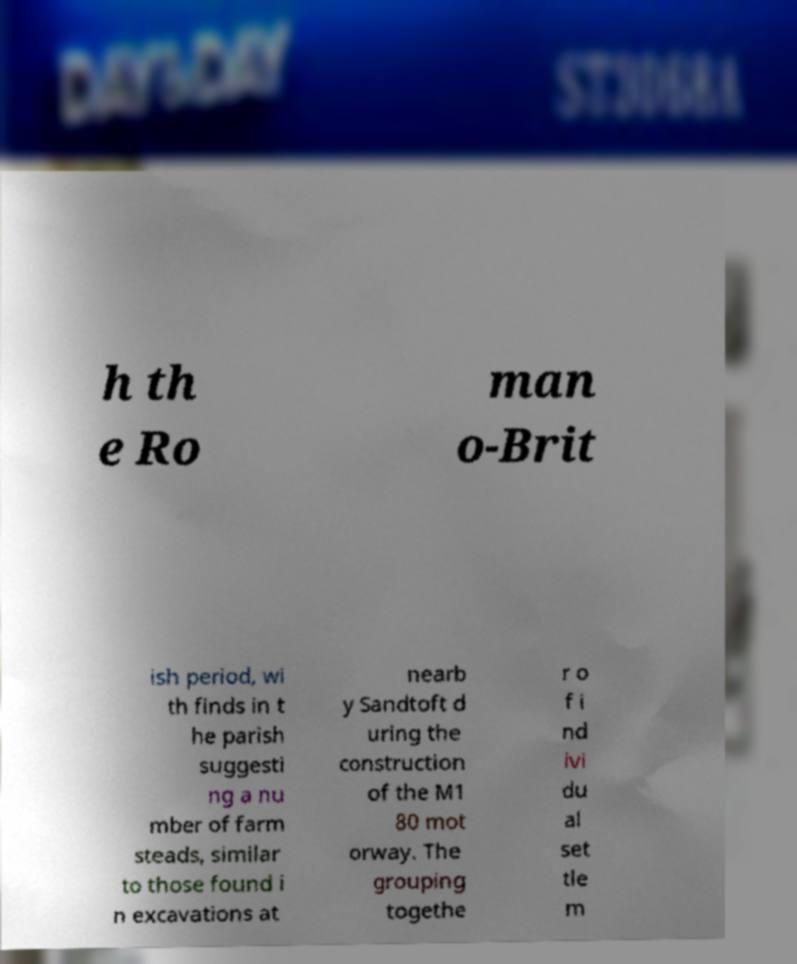For documentation purposes, I need the text within this image transcribed. Could you provide that? h th e Ro man o-Brit ish period, wi th finds in t he parish suggesti ng a nu mber of farm steads, similar to those found i n excavations at nearb y Sandtoft d uring the construction of the M1 80 mot orway. The grouping togethe r o f i nd ivi du al set tle m 